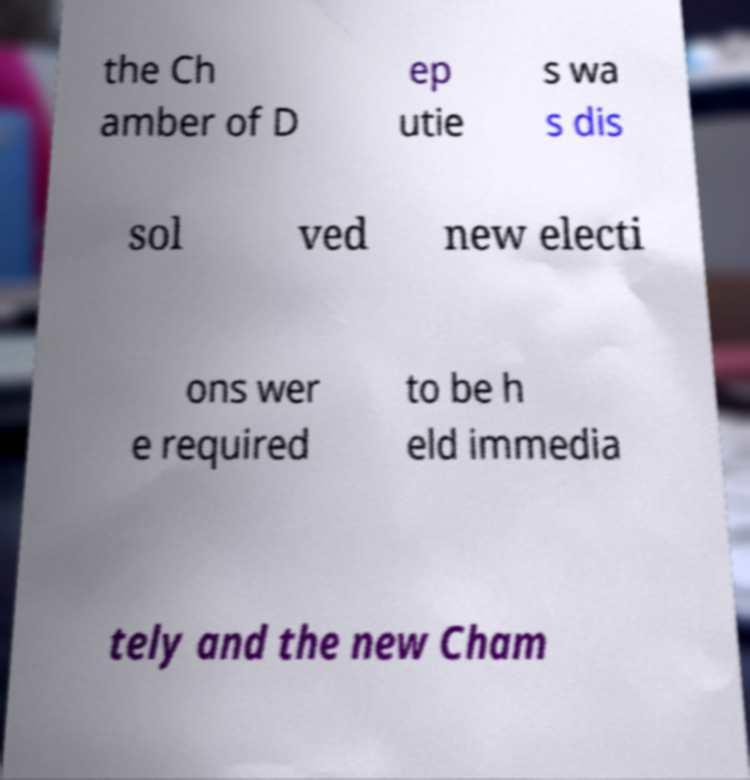Could you assist in decoding the text presented in this image and type it out clearly? the Ch amber of D ep utie s wa s dis sol ved new electi ons wer e required to be h eld immedia tely and the new Cham 